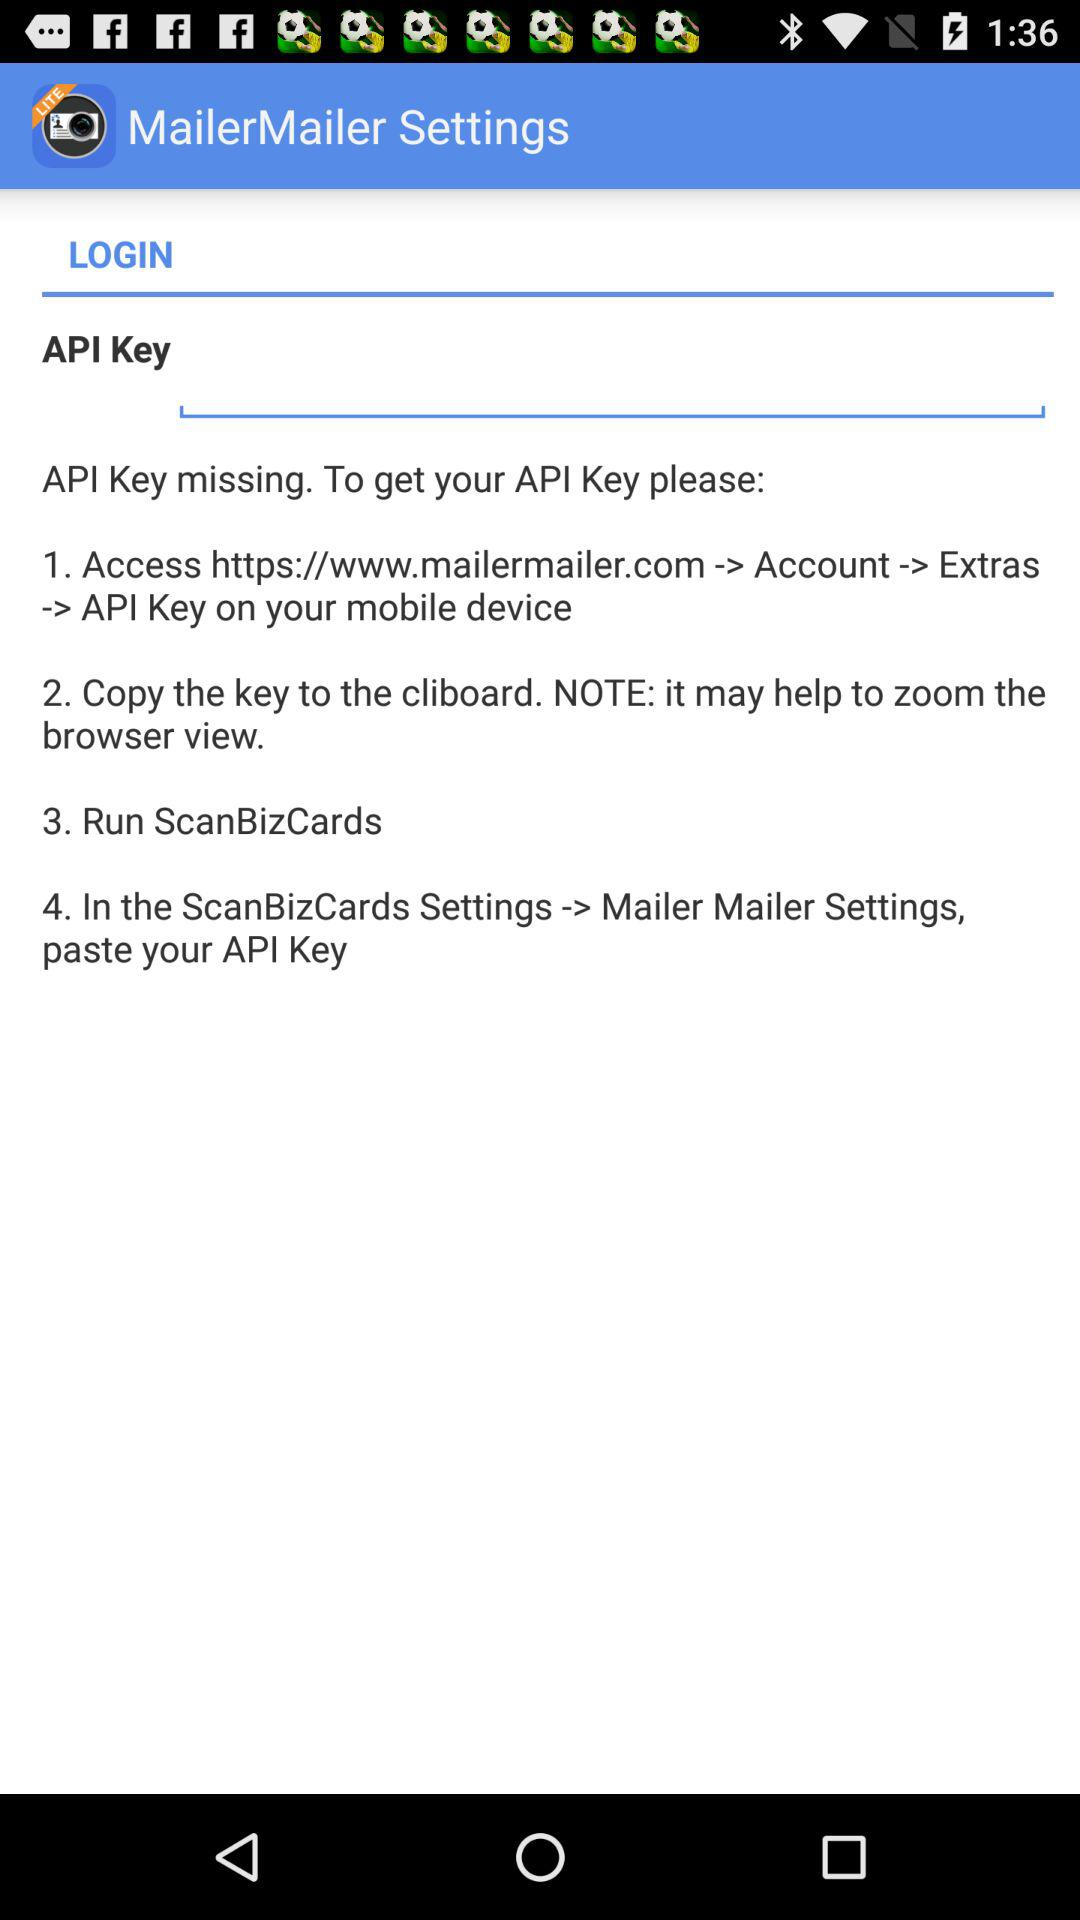How many steps are there in the API Key instructions?
Answer the question using a single word or phrase. 4 